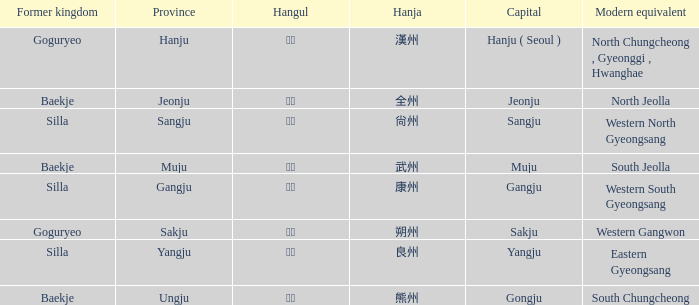The hanja 尙州 is for what capital? Sangju. 